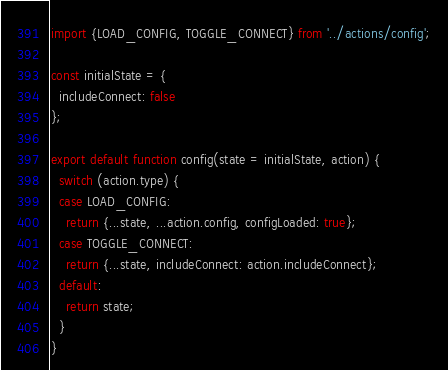Convert code to text. <code><loc_0><loc_0><loc_500><loc_500><_JavaScript_>import {LOAD_CONFIG, TOGGLE_CONNECT} from '../actions/config';

const initialState = {
  includeConnect: false
};

export default function config(state = initialState, action) {
  switch (action.type) {
  case LOAD_CONFIG:
    return {...state, ...action.config, configLoaded: true};
  case TOGGLE_CONNECT:
    return {...state, includeConnect: action.includeConnect};
  default:
    return state;
  }
}
</code> 